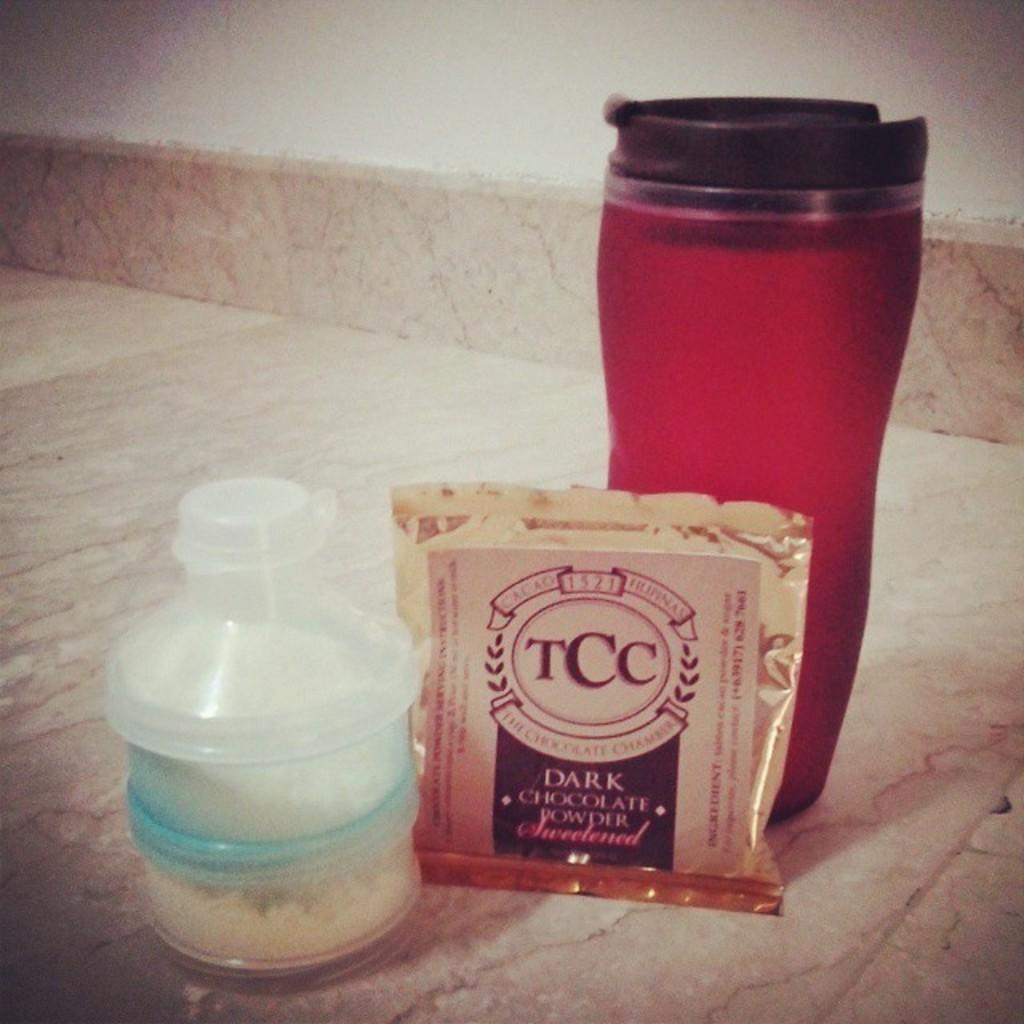<image>
Share a concise interpretation of the image provided. A packet of dark chocolate powdered sweetner next to a red cup and small bottle of white powder. 